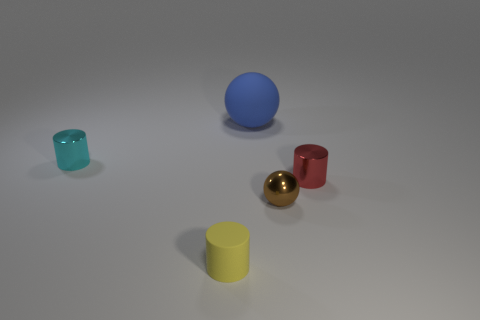Are there fewer blue things than green rubber cylinders?
Make the answer very short. No. There is a yellow cylinder that is the same size as the brown shiny ball; what material is it?
Offer a very short reply. Rubber. Is the number of tiny cyan metallic cylinders greater than the number of cyan matte cylinders?
Make the answer very short. Yes. How many other things are the same color as the large rubber sphere?
Your answer should be very brief. 0. How many tiny objects are both left of the small brown metallic thing and behind the small brown object?
Provide a short and direct response. 1. Are there any other things that are the same size as the matte ball?
Your answer should be compact. No. Are there more metal objects that are on the right side of the small rubber object than tiny red cylinders in front of the tiny red cylinder?
Your answer should be very brief. Yes. There is a ball behind the cyan metallic cylinder; what material is it?
Provide a succinct answer. Rubber. Does the tiny cyan metallic thing have the same shape as the rubber object in front of the cyan cylinder?
Your answer should be very brief. Yes. There is a shiny cylinder to the left of the small cylinder right of the big blue sphere; how many tiny spheres are on the right side of it?
Give a very brief answer. 1. 